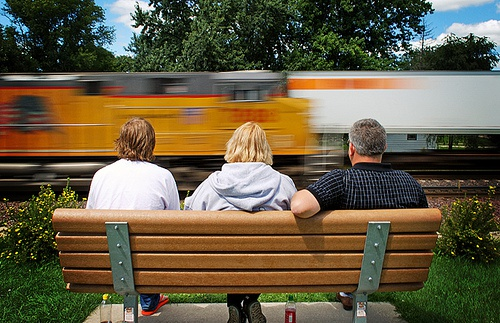Describe the objects in this image and their specific colors. I can see train in lightblue, orange, black, lightgray, and gray tones, bench in lightblue, brown, maroon, and black tones, people in lightblue, black, and gray tones, people in lightblue, lavender, black, darkgray, and tan tones, and people in lightblue, white, maroon, black, and gray tones in this image. 